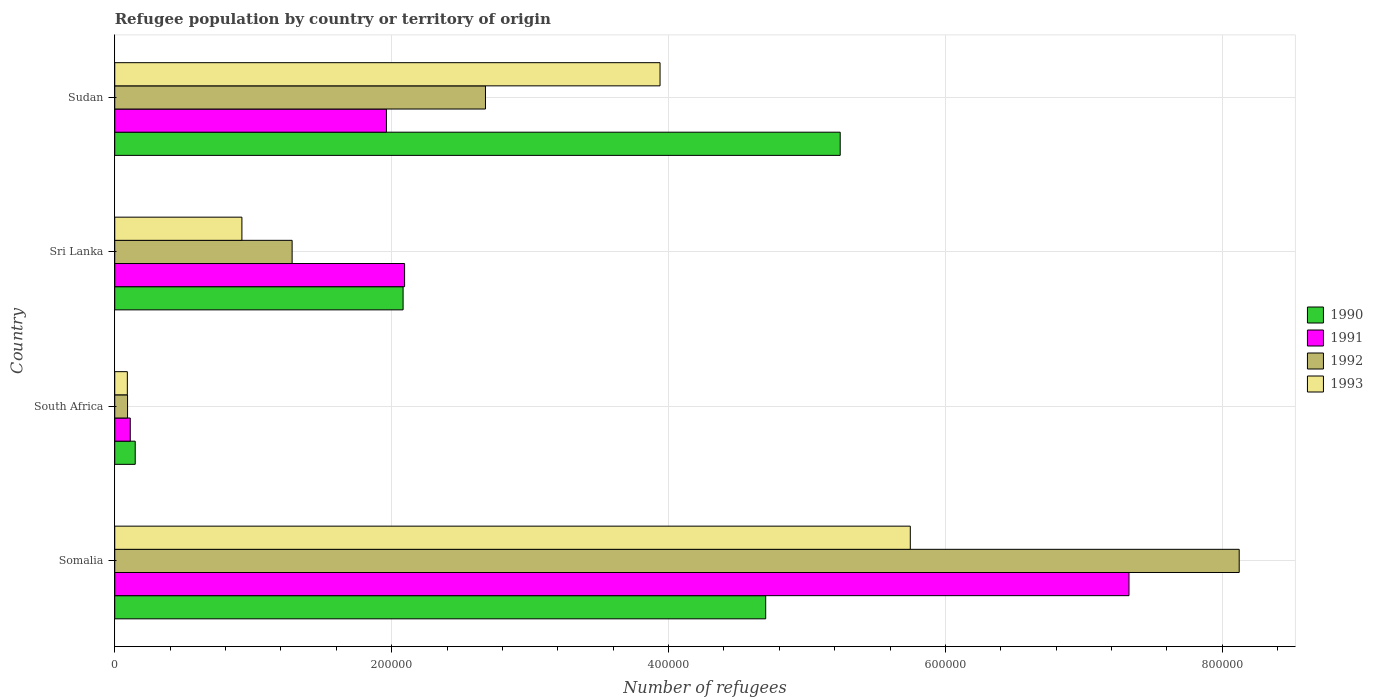How many bars are there on the 2nd tick from the top?
Offer a terse response. 4. What is the label of the 3rd group of bars from the top?
Your answer should be compact. South Africa. In how many cases, is the number of bars for a given country not equal to the number of legend labels?
Offer a very short reply. 0. What is the number of refugees in 1993 in Sri Lanka?
Your answer should be compact. 9.18e+04. Across all countries, what is the maximum number of refugees in 1990?
Ensure brevity in your answer.  5.24e+05. Across all countries, what is the minimum number of refugees in 1991?
Your answer should be compact. 1.12e+04. In which country was the number of refugees in 1992 maximum?
Offer a very short reply. Somalia. In which country was the number of refugees in 1993 minimum?
Offer a very short reply. South Africa. What is the total number of refugees in 1990 in the graph?
Give a very brief answer. 1.22e+06. What is the difference between the number of refugees in 1992 in Somalia and that in Sri Lanka?
Your response must be concise. 6.84e+05. What is the difference between the number of refugees in 1991 in Sudan and the number of refugees in 1992 in South Africa?
Make the answer very short. 1.87e+05. What is the average number of refugees in 1992 per country?
Your answer should be compact. 3.04e+05. What is the difference between the number of refugees in 1991 and number of refugees in 1990 in South Africa?
Offer a terse response. -3577. In how many countries, is the number of refugees in 1993 greater than 720000 ?
Your answer should be compact. 0. What is the ratio of the number of refugees in 1992 in Somalia to that in Sudan?
Ensure brevity in your answer.  3.03. Is the difference between the number of refugees in 1991 in South Africa and Sudan greater than the difference between the number of refugees in 1990 in South Africa and Sudan?
Provide a succinct answer. Yes. What is the difference between the highest and the second highest number of refugees in 1990?
Offer a terse response. 5.38e+04. What is the difference between the highest and the lowest number of refugees in 1993?
Make the answer very short. 5.66e+05. Is it the case that in every country, the sum of the number of refugees in 1991 and number of refugees in 1993 is greater than the sum of number of refugees in 1992 and number of refugees in 1990?
Your answer should be very brief. No. Is it the case that in every country, the sum of the number of refugees in 1990 and number of refugees in 1993 is greater than the number of refugees in 1992?
Make the answer very short. Yes. How many bars are there?
Keep it short and to the point. 16. Are all the bars in the graph horizontal?
Your answer should be compact. Yes. How many countries are there in the graph?
Provide a short and direct response. 4. What is the difference between two consecutive major ticks on the X-axis?
Offer a terse response. 2.00e+05. Are the values on the major ticks of X-axis written in scientific E-notation?
Give a very brief answer. No. Does the graph contain any zero values?
Ensure brevity in your answer.  No. How many legend labels are there?
Give a very brief answer. 4. How are the legend labels stacked?
Give a very brief answer. Vertical. What is the title of the graph?
Provide a short and direct response. Refugee population by country or territory of origin. What is the label or title of the X-axis?
Ensure brevity in your answer.  Number of refugees. What is the label or title of the Y-axis?
Provide a short and direct response. Country. What is the Number of refugees in 1990 in Somalia?
Ensure brevity in your answer.  4.70e+05. What is the Number of refugees of 1991 in Somalia?
Your answer should be compact. 7.33e+05. What is the Number of refugees in 1992 in Somalia?
Make the answer very short. 8.12e+05. What is the Number of refugees of 1993 in Somalia?
Your answer should be compact. 5.75e+05. What is the Number of refugees of 1990 in South Africa?
Provide a succinct answer. 1.48e+04. What is the Number of refugees in 1991 in South Africa?
Make the answer very short. 1.12e+04. What is the Number of refugees in 1992 in South Africa?
Offer a terse response. 9241. What is the Number of refugees in 1993 in South Africa?
Your answer should be compact. 9094. What is the Number of refugees in 1990 in Sri Lanka?
Ensure brevity in your answer.  2.08e+05. What is the Number of refugees of 1991 in Sri Lanka?
Your answer should be compact. 2.09e+05. What is the Number of refugees in 1992 in Sri Lanka?
Provide a succinct answer. 1.28e+05. What is the Number of refugees in 1993 in Sri Lanka?
Provide a succinct answer. 9.18e+04. What is the Number of refugees in 1990 in Sudan?
Provide a succinct answer. 5.24e+05. What is the Number of refugees in 1991 in Sudan?
Give a very brief answer. 1.96e+05. What is the Number of refugees of 1992 in Sudan?
Provide a short and direct response. 2.68e+05. What is the Number of refugees in 1993 in Sudan?
Give a very brief answer. 3.94e+05. Across all countries, what is the maximum Number of refugees of 1990?
Provide a succinct answer. 5.24e+05. Across all countries, what is the maximum Number of refugees in 1991?
Your answer should be compact. 7.33e+05. Across all countries, what is the maximum Number of refugees in 1992?
Your response must be concise. 8.12e+05. Across all countries, what is the maximum Number of refugees in 1993?
Give a very brief answer. 5.75e+05. Across all countries, what is the minimum Number of refugees in 1990?
Your response must be concise. 1.48e+04. Across all countries, what is the minimum Number of refugees of 1991?
Give a very brief answer. 1.12e+04. Across all countries, what is the minimum Number of refugees in 1992?
Give a very brief answer. 9241. Across all countries, what is the minimum Number of refugees of 1993?
Offer a terse response. 9094. What is the total Number of refugees in 1990 in the graph?
Your answer should be very brief. 1.22e+06. What is the total Number of refugees in 1991 in the graph?
Give a very brief answer. 1.15e+06. What is the total Number of refugees in 1992 in the graph?
Make the answer very short. 1.22e+06. What is the total Number of refugees in 1993 in the graph?
Provide a succinct answer. 1.07e+06. What is the difference between the Number of refugees in 1990 in Somalia and that in South Africa?
Provide a short and direct response. 4.55e+05. What is the difference between the Number of refugees in 1991 in Somalia and that in South Africa?
Provide a short and direct response. 7.21e+05. What is the difference between the Number of refugees of 1992 in Somalia and that in South Africa?
Provide a succinct answer. 8.03e+05. What is the difference between the Number of refugees of 1993 in Somalia and that in South Africa?
Your answer should be very brief. 5.66e+05. What is the difference between the Number of refugees in 1990 in Somalia and that in Sri Lanka?
Provide a short and direct response. 2.62e+05. What is the difference between the Number of refugees in 1991 in Somalia and that in Sri Lanka?
Provide a succinct answer. 5.23e+05. What is the difference between the Number of refugees in 1992 in Somalia and that in Sri Lanka?
Your answer should be compact. 6.84e+05. What is the difference between the Number of refugees in 1993 in Somalia and that in Sri Lanka?
Offer a very short reply. 4.83e+05. What is the difference between the Number of refugees in 1990 in Somalia and that in Sudan?
Ensure brevity in your answer.  -5.38e+04. What is the difference between the Number of refugees in 1991 in Somalia and that in Sudan?
Offer a terse response. 5.36e+05. What is the difference between the Number of refugees in 1992 in Somalia and that in Sudan?
Provide a short and direct response. 5.44e+05. What is the difference between the Number of refugees in 1993 in Somalia and that in Sudan?
Your response must be concise. 1.81e+05. What is the difference between the Number of refugees of 1990 in South Africa and that in Sri Lanka?
Your answer should be very brief. -1.93e+05. What is the difference between the Number of refugees in 1991 in South Africa and that in Sri Lanka?
Provide a succinct answer. -1.98e+05. What is the difference between the Number of refugees in 1992 in South Africa and that in Sri Lanka?
Your answer should be compact. -1.19e+05. What is the difference between the Number of refugees in 1993 in South Africa and that in Sri Lanka?
Your answer should be very brief. -8.28e+04. What is the difference between the Number of refugees of 1990 in South Africa and that in Sudan?
Your answer should be compact. -5.09e+05. What is the difference between the Number of refugees in 1991 in South Africa and that in Sudan?
Make the answer very short. -1.85e+05. What is the difference between the Number of refugees of 1992 in South Africa and that in Sudan?
Provide a succinct answer. -2.59e+05. What is the difference between the Number of refugees in 1993 in South Africa and that in Sudan?
Offer a terse response. -3.85e+05. What is the difference between the Number of refugees in 1990 in Sri Lanka and that in Sudan?
Offer a very short reply. -3.16e+05. What is the difference between the Number of refugees in 1991 in Sri Lanka and that in Sudan?
Offer a terse response. 1.31e+04. What is the difference between the Number of refugees of 1992 in Sri Lanka and that in Sudan?
Provide a succinct answer. -1.40e+05. What is the difference between the Number of refugees of 1993 in Sri Lanka and that in Sudan?
Your answer should be very brief. -3.02e+05. What is the difference between the Number of refugees in 1990 in Somalia and the Number of refugees in 1991 in South Africa?
Offer a terse response. 4.59e+05. What is the difference between the Number of refugees in 1990 in Somalia and the Number of refugees in 1992 in South Africa?
Offer a very short reply. 4.61e+05. What is the difference between the Number of refugees in 1990 in Somalia and the Number of refugees in 1993 in South Africa?
Your answer should be very brief. 4.61e+05. What is the difference between the Number of refugees in 1991 in Somalia and the Number of refugees in 1992 in South Africa?
Provide a short and direct response. 7.23e+05. What is the difference between the Number of refugees of 1991 in Somalia and the Number of refugees of 1993 in South Africa?
Provide a short and direct response. 7.24e+05. What is the difference between the Number of refugees of 1992 in Somalia and the Number of refugees of 1993 in South Africa?
Offer a very short reply. 8.03e+05. What is the difference between the Number of refugees in 1990 in Somalia and the Number of refugees in 1991 in Sri Lanka?
Make the answer very short. 2.61e+05. What is the difference between the Number of refugees in 1990 in Somalia and the Number of refugees in 1992 in Sri Lanka?
Keep it short and to the point. 3.42e+05. What is the difference between the Number of refugees of 1990 in Somalia and the Number of refugees of 1993 in Sri Lanka?
Provide a succinct answer. 3.78e+05. What is the difference between the Number of refugees of 1991 in Somalia and the Number of refugees of 1992 in Sri Lanka?
Provide a succinct answer. 6.04e+05. What is the difference between the Number of refugees in 1991 in Somalia and the Number of refugees in 1993 in Sri Lanka?
Your response must be concise. 6.41e+05. What is the difference between the Number of refugees in 1992 in Somalia and the Number of refugees in 1993 in Sri Lanka?
Your answer should be very brief. 7.20e+05. What is the difference between the Number of refugees in 1990 in Somalia and the Number of refugees in 1991 in Sudan?
Keep it short and to the point. 2.74e+05. What is the difference between the Number of refugees in 1990 in Somalia and the Number of refugees in 1992 in Sudan?
Make the answer very short. 2.02e+05. What is the difference between the Number of refugees in 1990 in Somalia and the Number of refugees in 1993 in Sudan?
Keep it short and to the point. 7.63e+04. What is the difference between the Number of refugees in 1991 in Somalia and the Number of refugees in 1992 in Sudan?
Your answer should be very brief. 4.65e+05. What is the difference between the Number of refugees of 1991 in Somalia and the Number of refugees of 1993 in Sudan?
Your answer should be compact. 3.39e+05. What is the difference between the Number of refugees of 1992 in Somalia and the Number of refugees of 1993 in Sudan?
Your answer should be compact. 4.18e+05. What is the difference between the Number of refugees of 1990 in South Africa and the Number of refugees of 1991 in Sri Lanka?
Ensure brevity in your answer.  -1.95e+05. What is the difference between the Number of refugees of 1990 in South Africa and the Number of refugees of 1992 in Sri Lanka?
Your answer should be very brief. -1.13e+05. What is the difference between the Number of refugees of 1990 in South Africa and the Number of refugees of 1993 in Sri Lanka?
Your answer should be compact. -7.71e+04. What is the difference between the Number of refugees in 1991 in South Africa and the Number of refugees in 1992 in Sri Lanka?
Provide a succinct answer. -1.17e+05. What is the difference between the Number of refugees in 1991 in South Africa and the Number of refugees in 1993 in Sri Lanka?
Your response must be concise. -8.06e+04. What is the difference between the Number of refugees of 1992 in South Africa and the Number of refugees of 1993 in Sri Lanka?
Your answer should be very brief. -8.26e+04. What is the difference between the Number of refugees in 1990 in South Africa and the Number of refugees in 1991 in Sudan?
Your answer should be compact. -1.81e+05. What is the difference between the Number of refugees in 1990 in South Africa and the Number of refugees in 1992 in Sudan?
Offer a terse response. -2.53e+05. What is the difference between the Number of refugees of 1990 in South Africa and the Number of refugees of 1993 in Sudan?
Keep it short and to the point. -3.79e+05. What is the difference between the Number of refugees of 1991 in South Africa and the Number of refugees of 1992 in Sudan?
Offer a very short reply. -2.57e+05. What is the difference between the Number of refugees in 1991 in South Africa and the Number of refugees in 1993 in Sudan?
Provide a succinct answer. -3.83e+05. What is the difference between the Number of refugees of 1992 in South Africa and the Number of refugees of 1993 in Sudan?
Ensure brevity in your answer.  -3.85e+05. What is the difference between the Number of refugees of 1990 in Sri Lanka and the Number of refugees of 1991 in Sudan?
Provide a short and direct response. 1.20e+04. What is the difference between the Number of refugees in 1990 in Sri Lanka and the Number of refugees in 1992 in Sudan?
Provide a short and direct response. -5.95e+04. What is the difference between the Number of refugees of 1990 in Sri Lanka and the Number of refugees of 1993 in Sudan?
Keep it short and to the point. -1.86e+05. What is the difference between the Number of refugees of 1991 in Sri Lanka and the Number of refugees of 1992 in Sudan?
Offer a very short reply. -5.84e+04. What is the difference between the Number of refugees in 1991 in Sri Lanka and the Number of refugees in 1993 in Sudan?
Offer a terse response. -1.85e+05. What is the difference between the Number of refugees of 1992 in Sri Lanka and the Number of refugees of 1993 in Sudan?
Ensure brevity in your answer.  -2.66e+05. What is the average Number of refugees of 1990 per country?
Make the answer very short. 3.04e+05. What is the average Number of refugees in 1991 per country?
Make the answer very short. 2.87e+05. What is the average Number of refugees in 1992 per country?
Ensure brevity in your answer.  3.04e+05. What is the average Number of refugees in 1993 per country?
Provide a succinct answer. 2.67e+05. What is the difference between the Number of refugees of 1990 and Number of refugees of 1991 in Somalia?
Keep it short and to the point. -2.62e+05. What is the difference between the Number of refugees in 1990 and Number of refugees in 1992 in Somalia?
Ensure brevity in your answer.  -3.42e+05. What is the difference between the Number of refugees in 1990 and Number of refugees in 1993 in Somalia?
Keep it short and to the point. -1.04e+05. What is the difference between the Number of refugees in 1991 and Number of refugees in 1992 in Somalia?
Ensure brevity in your answer.  -7.96e+04. What is the difference between the Number of refugees of 1991 and Number of refugees of 1993 in Somalia?
Keep it short and to the point. 1.58e+05. What is the difference between the Number of refugees of 1992 and Number of refugees of 1993 in Somalia?
Provide a succinct answer. 2.38e+05. What is the difference between the Number of refugees in 1990 and Number of refugees in 1991 in South Africa?
Offer a terse response. 3577. What is the difference between the Number of refugees in 1990 and Number of refugees in 1992 in South Africa?
Your answer should be compact. 5542. What is the difference between the Number of refugees of 1990 and Number of refugees of 1993 in South Africa?
Give a very brief answer. 5689. What is the difference between the Number of refugees of 1991 and Number of refugees of 1992 in South Africa?
Your response must be concise. 1965. What is the difference between the Number of refugees in 1991 and Number of refugees in 1993 in South Africa?
Ensure brevity in your answer.  2112. What is the difference between the Number of refugees of 1992 and Number of refugees of 1993 in South Africa?
Offer a terse response. 147. What is the difference between the Number of refugees in 1990 and Number of refugees in 1991 in Sri Lanka?
Your answer should be very brief. -1078. What is the difference between the Number of refugees in 1990 and Number of refugees in 1992 in Sri Lanka?
Offer a very short reply. 8.02e+04. What is the difference between the Number of refugees of 1990 and Number of refugees of 1993 in Sri Lanka?
Keep it short and to the point. 1.16e+05. What is the difference between the Number of refugees in 1991 and Number of refugees in 1992 in Sri Lanka?
Provide a short and direct response. 8.12e+04. What is the difference between the Number of refugees in 1991 and Number of refugees in 1993 in Sri Lanka?
Your answer should be very brief. 1.18e+05. What is the difference between the Number of refugees of 1992 and Number of refugees of 1993 in Sri Lanka?
Provide a short and direct response. 3.63e+04. What is the difference between the Number of refugees of 1990 and Number of refugees of 1991 in Sudan?
Give a very brief answer. 3.28e+05. What is the difference between the Number of refugees of 1990 and Number of refugees of 1992 in Sudan?
Ensure brevity in your answer.  2.56e+05. What is the difference between the Number of refugees of 1990 and Number of refugees of 1993 in Sudan?
Your answer should be compact. 1.30e+05. What is the difference between the Number of refugees in 1991 and Number of refugees in 1992 in Sudan?
Offer a terse response. -7.15e+04. What is the difference between the Number of refugees in 1991 and Number of refugees in 1993 in Sudan?
Provide a short and direct response. -1.98e+05. What is the difference between the Number of refugees in 1992 and Number of refugees in 1993 in Sudan?
Ensure brevity in your answer.  -1.26e+05. What is the ratio of the Number of refugees of 1990 in Somalia to that in South Africa?
Provide a succinct answer. 31.8. What is the ratio of the Number of refugees in 1991 in Somalia to that in South Africa?
Provide a short and direct response. 65.38. What is the ratio of the Number of refugees in 1992 in Somalia to that in South Africa?
Provide a succinct answer. 87.89. What is the ratio of the Number of refugees of 1993 in Somalia to that in South Africa?
Provide a succinct answer. 63.19. What is the ratio of the Number of refugees in 1990 in Somalia to that in Sri Lanka?
Your response must be concise. 2.26. What is the ratio of the Number of refugees of 1991 in Somalia to that in Sri Lanka?
Keep it short and to the point. 3.5. What is the ratio of the Number of refugees of 1992 in Somalia to that in Sri Lanka?
Your answer should be compact. 6.34. What is the ratio of the Number of refugees of 1993 in Somalia to that in Sri Lanka?
Your response must be concise. 6.26. What is the ratio of the Number of refugees in 1990 in Somalia to that in Sudan?
Your answer should be very brief. 0.9. What is the ratio of the Number of refugees of 1991 in Somalia to that in Sudan?
Provide a succinct answer. 3.73. What is the ratio of the Number of refugees in 1992 in Somalia to that in Sudan?
Your answer should be compact. 3.03. What is the ratio of the Number of refugees of 1993 in Somalia to that in Sudan?
Ensure brevity in your answer.  1.46. What is the ratio of the Number of refugees of 1990 in South Africa to that in Sri Lanka?
Make the answer very short. 0.07. What is the ratio of the Number of refugees of 1991 in South Africa to that in Sri Lanka?
Ensure brevity in your answer.  0.05. What is the ratio of the Number of refugees of 1992 in South Africa to that in Sri Lanka?
Make the answer very short. 0.07. What is the ratio of the Number of refugees of 1993 in South Africa to that in Sri Lanka?
Give a very brief answer. 0.1. What is the ratio of the Number of refugees of 1990 in South Africa to that in Sudan?
Your answer should be very brief. 0.03. What is the ratio of the Number of refugees of 1991 in South Africa to that in Sudan?
Your answer should be very brief. 0.06. What is the ratio of the Number of refugees in 1992 in South Africa to that in Sudan?
Make the answer very short. 0.03. What is the ratio of the Number of refugees of 1993 in South Africa to that in Sudan?
Your answer should be compact. 0.02. What is the ratio of the Number of refugees of 1990 in Sri Lanka to that in Sudan?
Make the answer very short. 0.4. What is the ratio of the Number of refugees of 1991 in Sri Lanka to that in Sudan?
Ensure brevity in your answer.  1.07. What is the ratio of the Number of refugees of 1992 in Sri Lanka to that in Sudan?
Ensure brevity in your answer.  0.48. What is the ratio of the Number of refugees in 1993 in Sri Lanka to that in Sudan?
Offer a very short reply. 0.23. What is the difference between the highest and the second highest Number of refugees of 1990?
Ensure brevity in your answer.  5.38e+04. What is the difference between the highest and the second highest Number of refugees of 1991?
Keep it short and to the point. 5.23e+05. What is the difference between the highest and the second highest Number of refugees in 1992?
Provide a short and direct response. 5.44e+05. What is the difference between the highest and the second highest Number of refugees in 1993?
Your answer should be very brief. 1.81e+05. What is the difference between the highest and the lowest Number of refugees in 1990?
Offer a terse response. 5.09e+05. What is the difference between the highest and the lowest Number of refugees in 1991?
Keep it short and to the point. 7.21e+05. What is the difference between the highest and the lowest Number of refugees in 1992?
Offer a very short reply. 8.03e+05. What is the difference between the highest and the lowest Number of refugees of 1993?
Provide a succinct answer. 5.66e+05. 